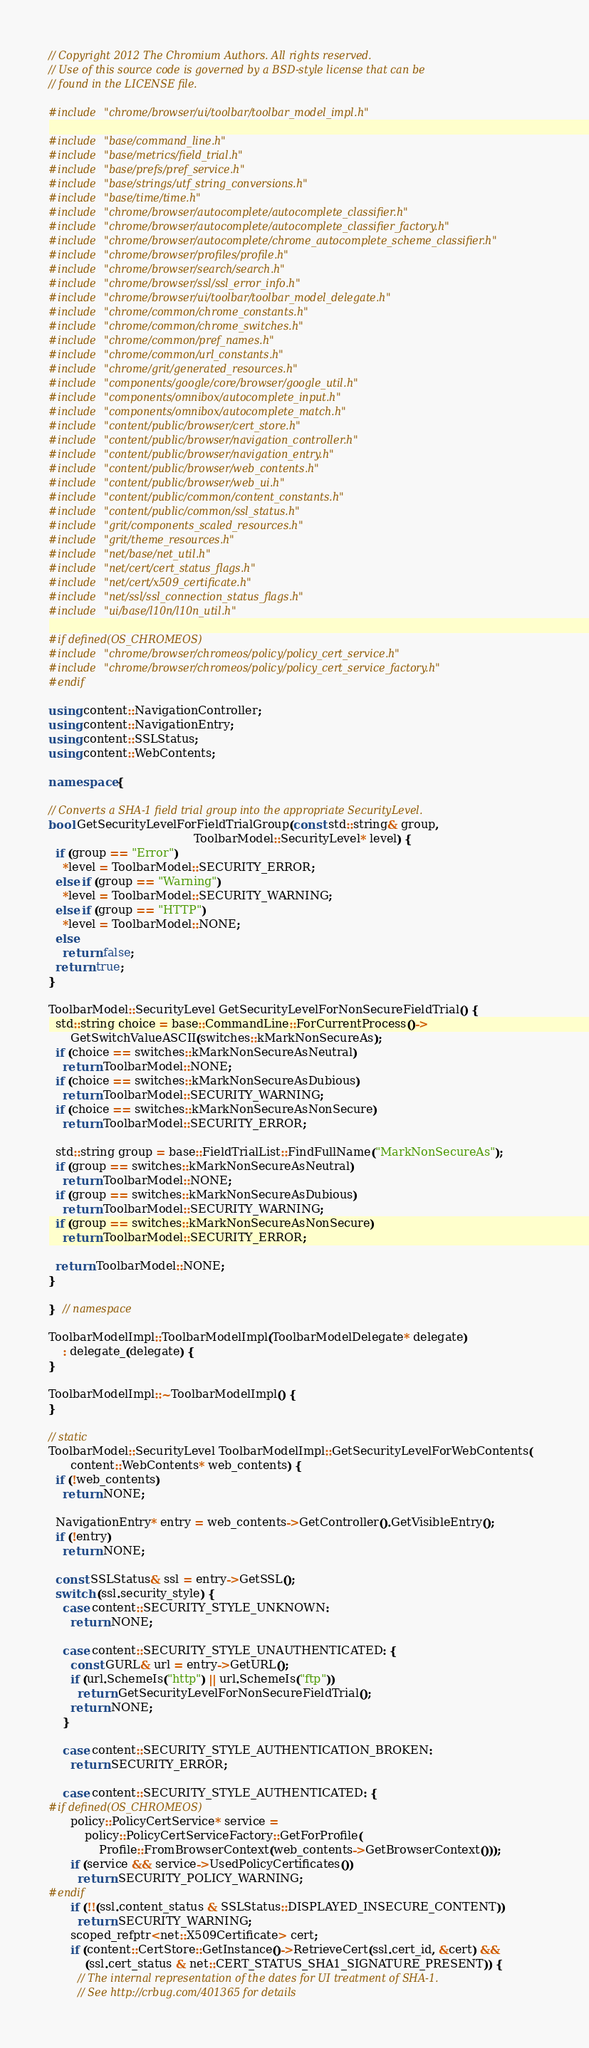Convert code to text. <code><loc_0><loc_0><loc_500><loc_500><_C++_>// Copyright 2012 The Chromium Authors. All rights reserved.
// Use of this source code is governed by a BSD-style license that can be
// found in the LICENSE file.

#include "chrome/browser/ui/toolbar/toolbar_model_impl.h"

#include "base/command_line.h"
#include "base/metrics/field_trial.h"
#include "base/prefs/pref_service.h"
#include "base/strings/utf_string_conversions.h"
#include "base/time/time.h"
#include "chrome/browser/autocomplete/autocomplete_classifier.h"
#include "chrome/browser/autocomplete/autocomplete_classifier_factory.h"
#include "chrome/browser/autocomplete/chrome_autocomplete_scheme_classifier.h"
#include "chrome/browser/profiles/profile.h"
#include "chrome/browser/search/search.h"
#include "chrome/browser/ssl/ssl_error_info.h"
#include "chrome/browser/ui/toolbar/toolbar_model_delegate.h"
#include "chrome/common/chrome_constants.h"
#include "chrome/common/chrome_switches.h"
#include "chrome/common/pref_names.h"
#include "chrome/common/url_constants.h"
#include "chrome/grit/generated_resources.h"
#include "components/google/core/browser/google_util.h"
#include "components/omnibox/autocomplete_input.h"
#include "components/omnibox/autocomplete_match.h"
#include "content/public/browser/cert_store.h"
#include "content/public/browser/navigation_controller.h"
#include "content/public/browser/navigation_entry.h"
#include "content/public/browser/web_contents.h"
#include "content/public/browser/web_ui.h"
#include "content/public/common/content_constants.h"
#include "content/public/common/ssl_status.h"
#include "grit/components_scaled_resources.h"
#include "grit/theme_resources.h"
#include "net/base/net_util.h"
#include "net/cert/cert_status_flags.h"
#include "net/cert/x509_certificate.h"
#include "net/ssl/ssl_connection_status_flags.h"
#include "ui/base/l10n/l10n_util.h"

#if defined(OS_CHROMEOS)
#include "chrome/browser/chromeos/policy/policy_cert_service.h"
#include "chrome/browser/chromeos/policy/policy_cert_service_factory.h"
#endif

using content::NavigationController;
using content::NavigationEntry;
using content::SSLStatus;
using content::WebContents;

namespace {

// Converts a SHA-1 field trial group into the appropriate SecurityLevel.
bool GetSecurityLevelForFieldTrialGroup(const std::string& group,
                                        ToolbarModel::SecurityLevel* level) {
  if (group == "Error")
    *level = ToolbarModel::SECURITY_ERROR;
  else if (group == "Warning")
    *level = ToolbarModel::SECURITY_WARNING;
  else if (group == "HTTP")
    *level = ToolbarModel::NONE;
  else
    return false;
  return true;
}

ToolbarModel::SecurityLevel GetSecurityLevelForNonSecureFieldTrial() {
  std::string choice = base::CommandLine::ForCurrentProcess()->
      GetSwitchValueASCII(switches::kMarkNonSecureAs);
  if (choice == switches::kMarkNonSecureAsNeutral)
    return ToolbarModel::NONE;
  if (choice == switches::kMarkNonSecureAsDubious)
    return ToolbarModel::SECURITY_WARNING;
  if (choice == switches::kMarkNonSecureAsNonSecure)
    return ToolbarModel::SECURITY_ERROR;

  std::string group = base::FieldTrialList::FindFullName("MarkNonSecureAs");
  if (group == switches::kMarkNonSecureAsNeutral)
    return ToolbarModel::NONE;
  if (group == switches::kMarkNonSecureAsDubious)
    return ToolbarModel::SECURITY_WARNING;
  if (group == switches::kMarkNonSecureAsNonSecure)
    return ToolbarModel::SECURITY_ERROR;

  return ToolbarModel::NONE;
}

}  // namespace

ToolbarModelImpl::ToolbarModelImpl(ToolbarModelDelegate* delegate)
    : delegate_(delegate) {
}

ToolbarModelImpl::~ToolbarModelImpl() {
}

// static
ToolbarModel::SecurityLevel ToolbarModelImpl::GetSecurityLevelForWebContents(
      content::WebContents* web_contents) {
  if (!web_contents)
    return NONE;

  NavigationEntry* entry = web_contents->GetController().GetVisibleEntry();
  if (!entry)
    return NONE;

  const SSLStatus& ssl = entry->GetSSL();
  switch (ssl.security_style) {
    case content::SECURITY_STYLE_UNKNOWN:
      return NONE;

    case content::SECURITY_STYLE_UNAUTHENTICATED: {
      const GURL& url = entry->GetURL();
      if (url.SchemeIs("http") || url.SchemeIs("ftp"))
        return GetSecurityLevelForNonSecureFieldTrial();
      return NONE;
    }

    case content::SECURITY_STYLE_AUTHENTICATION_BROKEN:
      return SECURITY_ERROR;

    case content::SECURITY_STYLE_AUTHENTICATED: {
#if defined(OS_CHROMEOS)
      policy::PolicyCertService* service =
          policy::PolicyCertServiceFactory::GetForProfile(
              Profile::FromBrowserContext(web_contents->GetBrowserContext()));
      if (service && service->UsedPolicyCertificates())
        return SECURITY_POLICY_WARNING;
#endif
      if (!!(ssl.content_status & SSLStatus::DISPLAYED_INSECURE_CONTENT))
        return SECURITY_WARNING;
      scoped_refptr<net::X509Certificate> cert;
      if (content::CertStore::GetInstance()->RetrieveCert(ssl.cert_id, &cert) &&
          (ssl.cert_status & net::CERT_STATUS_SHA1_SIGNATURE_PRESENT)) {
        // The internal representation of the dates for UI treatment of SHA-1.
        // See http://crbug.com/401365 for details</code> 